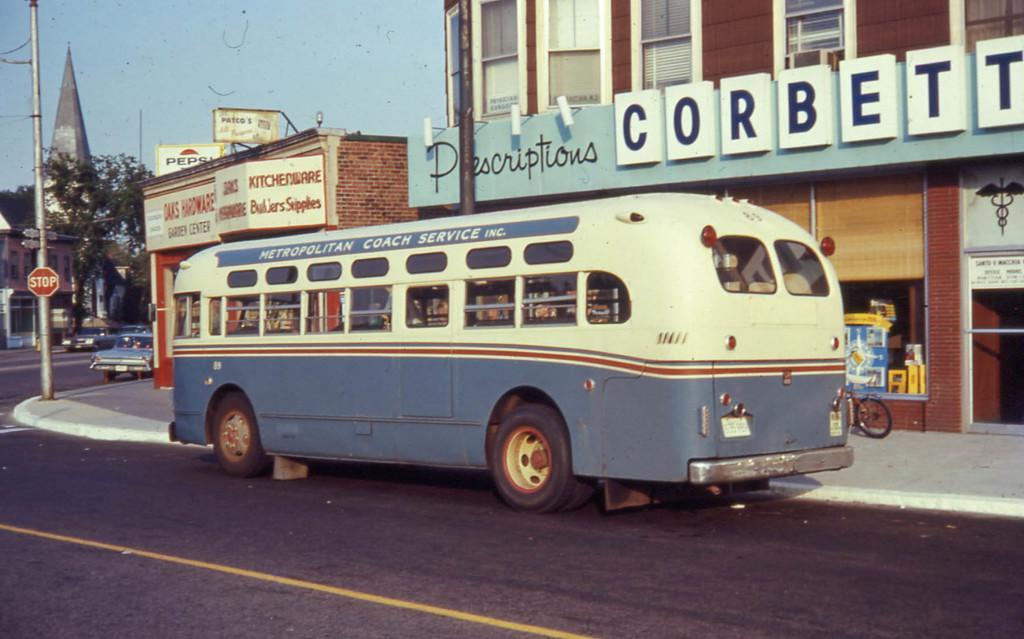Can you describe this image briefly? This is an outside view. Here I can see a bus on the road. On the the left side there are some cars. Beside the road there is a pole on the footpath. In the background, I can see some buildings and the trees. On the top of the image I can see the sky. On the right side there is a bicycle on the footpath. 